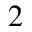Convert formula to latex. <formula><loc_0><loc_0><loc_500><loc_500>^ { 2 }</formula> 